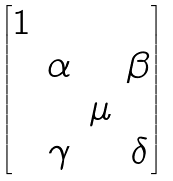<formula> <loc_0><loc_0><loc_500><loc_500>\begin{bmatrix} 1 \\ & \alpha & & \beta \\ & & \mu \\ & \gamma & & \delta \end{bmatrix}</formula> 